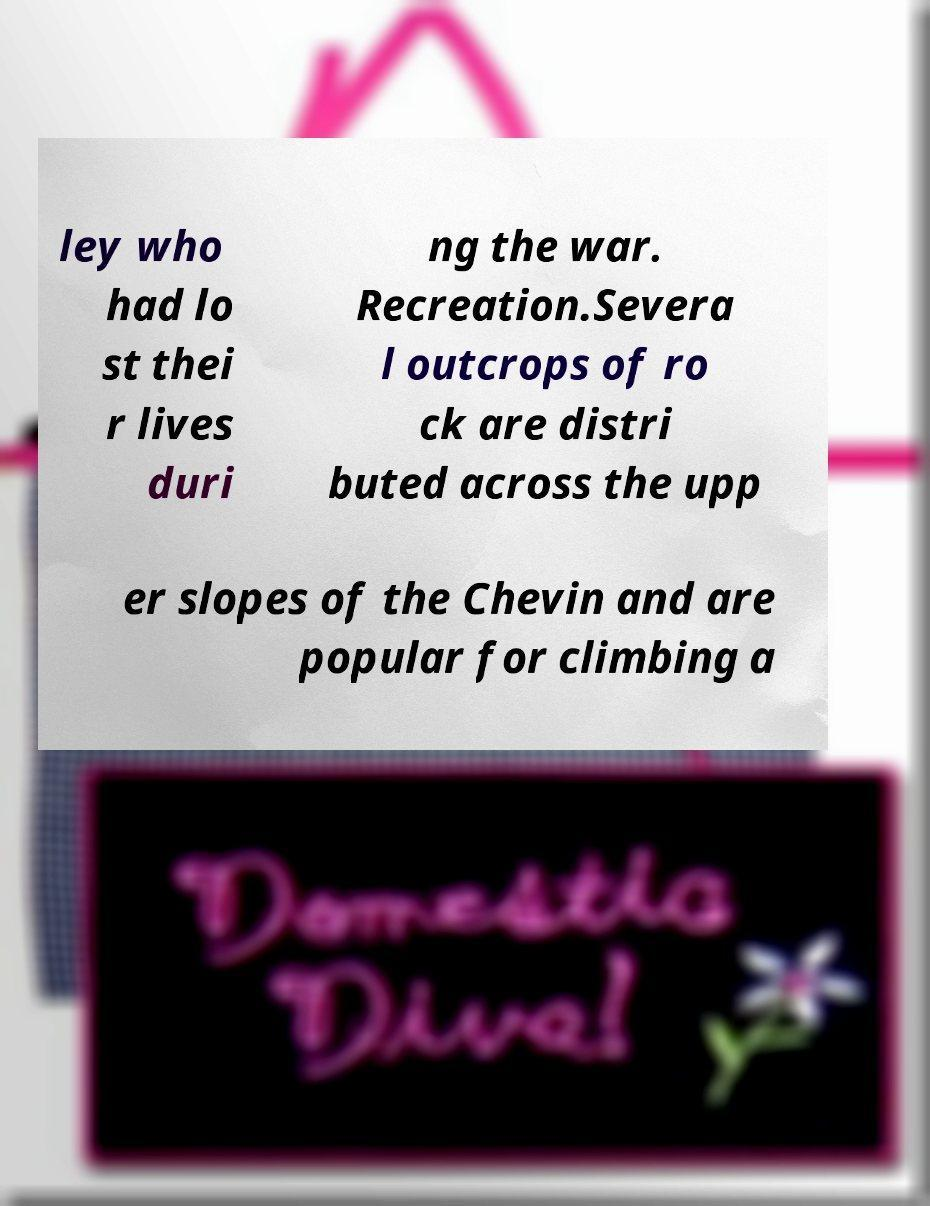Can you accurately transcribe the text from the provided image for me? ley who had lo st thei r lives duri ng the war. Recreation.Severa l outcrops of ro ck are distri buted across the upp er slopes of the Chevin and are popular for climbing a 